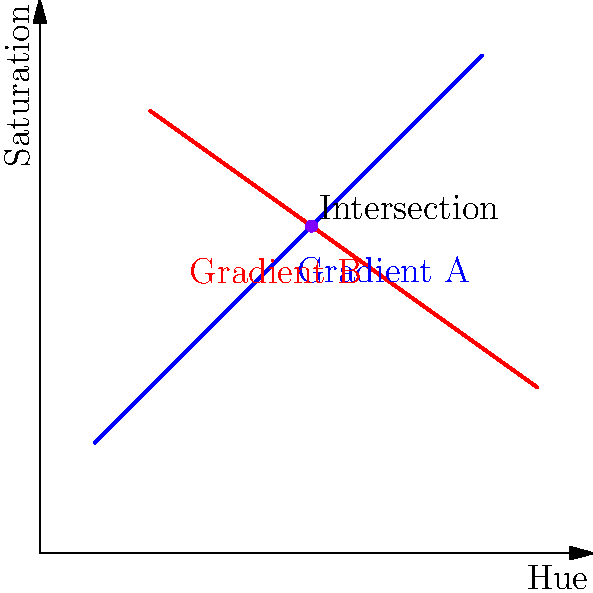In a color grading project, two color gradients are represented as lines on a 2D graph, where the x-axis represents hue and the y-axis represents saturation. Gradient A is defined by the points $(1,2)$ and $(8,9)$, while Gradient B is defined by the points $(2,8)$ and $(9,3)$. Determine the intersection point of these two color gradients. To find the intersection point of the two color gradients, we need to solve the system of linear equations representing the two lines. Let's approach this step-by-step:

1) First, let's find the equations of both lines in the slope-intercept form $(y = mx + b)$:

   For Gradient A:
   Slope $m_A = \frac{9-2}{8-1} = 1$
   $y = x + b$, and $(1,2)$ is on this line, so:
   $2 = 1 + b$, therefore $b = 1$
   Equation of Gradient A: $y = x + 1$

   For Gradient B:
   Slope $m_B = \frac{3-8}{9-2} = -\frac{5}{7}$
   $y = -\frac{5}{7}x + b$, and $(2,8)$ is on this line, so:
   $8 = -\frac{5}{7}(2) + b$, therefore $b = \frac{66}{7}$
   Equation of Gradient B: $y = -\frac{5}{7}x + \frac{66}{7}$

2) At the intersection point, the $x$ and $y$ coordinates will be the same for both equations. So we can set them equal:

   $x + 1 = -\frac{5}{7}x + \frac{66}{7}$

3) Solve for $x$:
   $7x + 7 = -5x + 66$
   $12x = 59$
   $x = \frac{59}{12}$

4) Substitute this $x$ value back into either equation to find $y$:
   $y = \frac{59}{12} + 1 = \frac{71}{12}$

Therefore, the intersection point is $(\frac{59}{12}, \frac{71}{12})$ or approximately $(4.92, 5.92)$.
Answer: $(\frac{59}{12}, \frac{71}{12})$ 